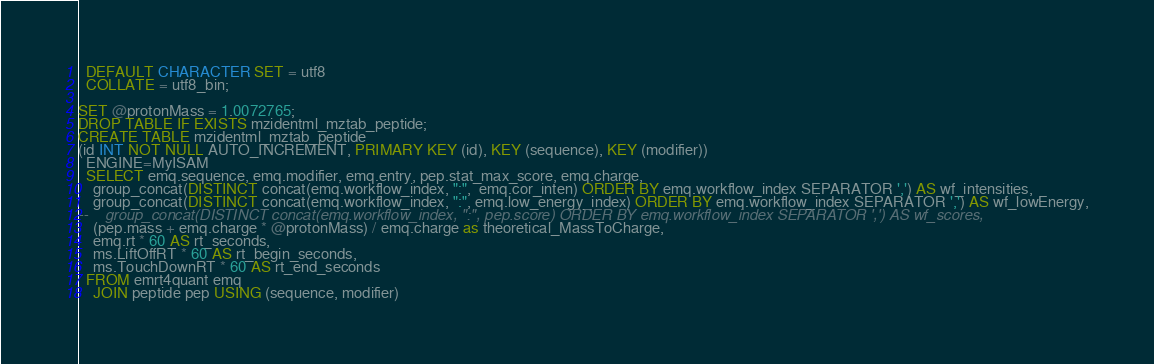<code> <loc_0><loc_0><loc_500><loc_500><_SQL_>  DEFAULT CHARACTER SET = utf8
  COLLATE = utf8_bin;

SET @protonMass = 1.0072765;
DROP TABLE IF EXISTS mzidentml_mztab_peptide;
CREATE TABLE mzidentml_mztab_peptide
(id INT NOT NULL AUTO_INCREMENT, PRIMARY KEY (id), KEY (sequence), KEY (modifier))
  ENGINE=MyISAM
  SELECT emq.sequence, emq.modifier, emq.entry, pep.stat_max_score, emq.charge,
    group_concat(DISTINCT concat(emq.workflow_index, ":",  emq.cor_inten) ORDER BY emq.workflow_index SEPARATOR ',') AS wf_intensities,
    group_concat(DISTINCT concat(emq.workflow_index, ":", emq.low_energy_index) ORDER BY emq.workflow_index SEPARATOR ',') AS wf_lowEnergy,
--    group_concat(DISTINCT concat(emq.workflow_index, ":", pep.score) ORDER BY emq.workflow_index SEPARATOR ',') AS wf_scores,
    (pep.mass + emq.charge * @protonMass) / emq.charge as theoretical_MassToCharge,
    emq.rt * 60 AS rt_seconds,
    ms.LiftOffRT * 60 AS rt_begin_seconds,
    ms.TouchDownRT * 60 AS rt_end_seconds
  FROM emrt4quant emq
    JOIN peptide pep USING (sequence, modifier)</code> 